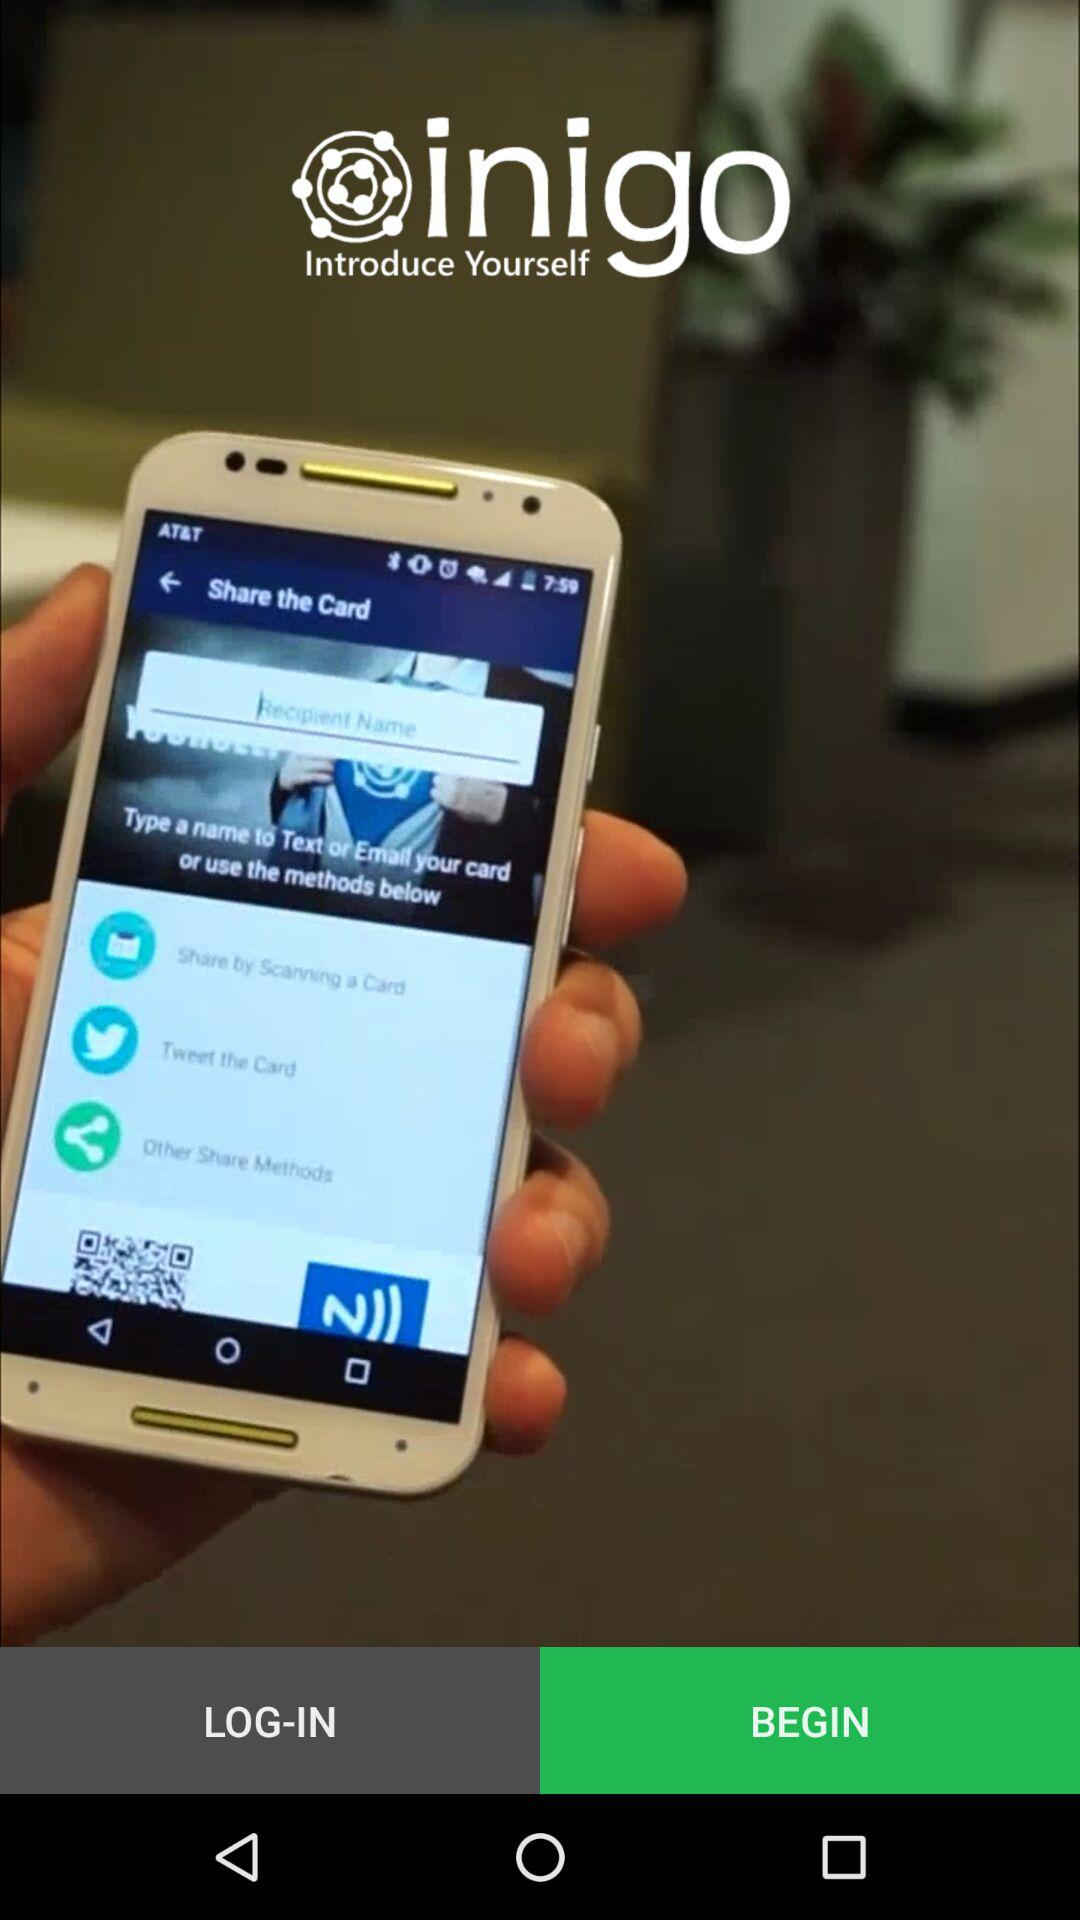What is the name of the application? The name of the application is "inigo". 